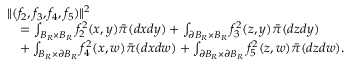<formula> <loc_0><loc_0><loc_500><loc_500>\begin{array} { r l } { { \| ( f _ { 2 } , f _ { 3 } , f _ { 4 } , f _ { 5 } ) \| ^ { 2 } } } \\ & { = \int _ { B _ { R } \times B _ { R } } f _ { 2 } ^ { 2 } ( x , y ) \bar { \pi } ( d x d y ) + \int _ { \partial B _ { R } \times B _ { R } } f _ { 3 } ^ { 2 } ( z , y ) \bar { \pi } ( d z d y ) } \\ & { + \int _ { B _ { R } \times \partial B _ { R } } f _ { 4 } ^ { 2 } ( x , w ) \bar { \pi } ( d x d w ) + \int _ { \partial B _ { R } \times \partial B _ { R } } f _ { 5 } ^ { 2 } ( z , w ) \bar { \pi } ( d z d w ) . } \end{array}</formula> 